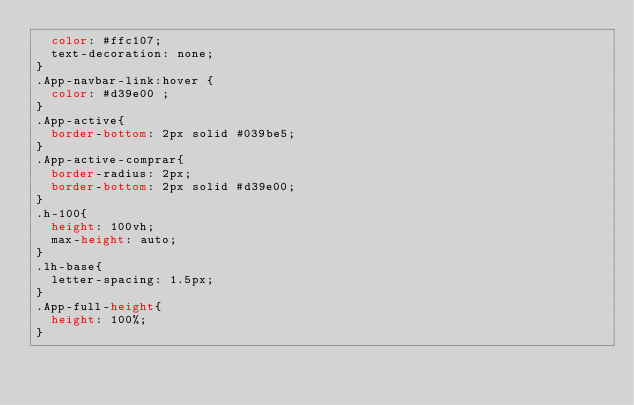Convert code to text. <code><loc_0><loc_0><loc_500><loc_500><_CSS_>  color: #ffc107;
  text-decoration: none;
}
.App-navbar-link:hover {
  color: #d39e00 ;
}
.App-active{
  border-bottom: 2px solid #039be5;
}
.App-active-comprar{
  border-radius: 2px;
  border-bottom: 2px solid #d39e00;
}
.h-100{
  height: 100vh;
  max-height: auto;
}
.lh-base{
  letter-spacing: 1.5px;
}
.App-full-height{
  height: 100%;
}</code> 